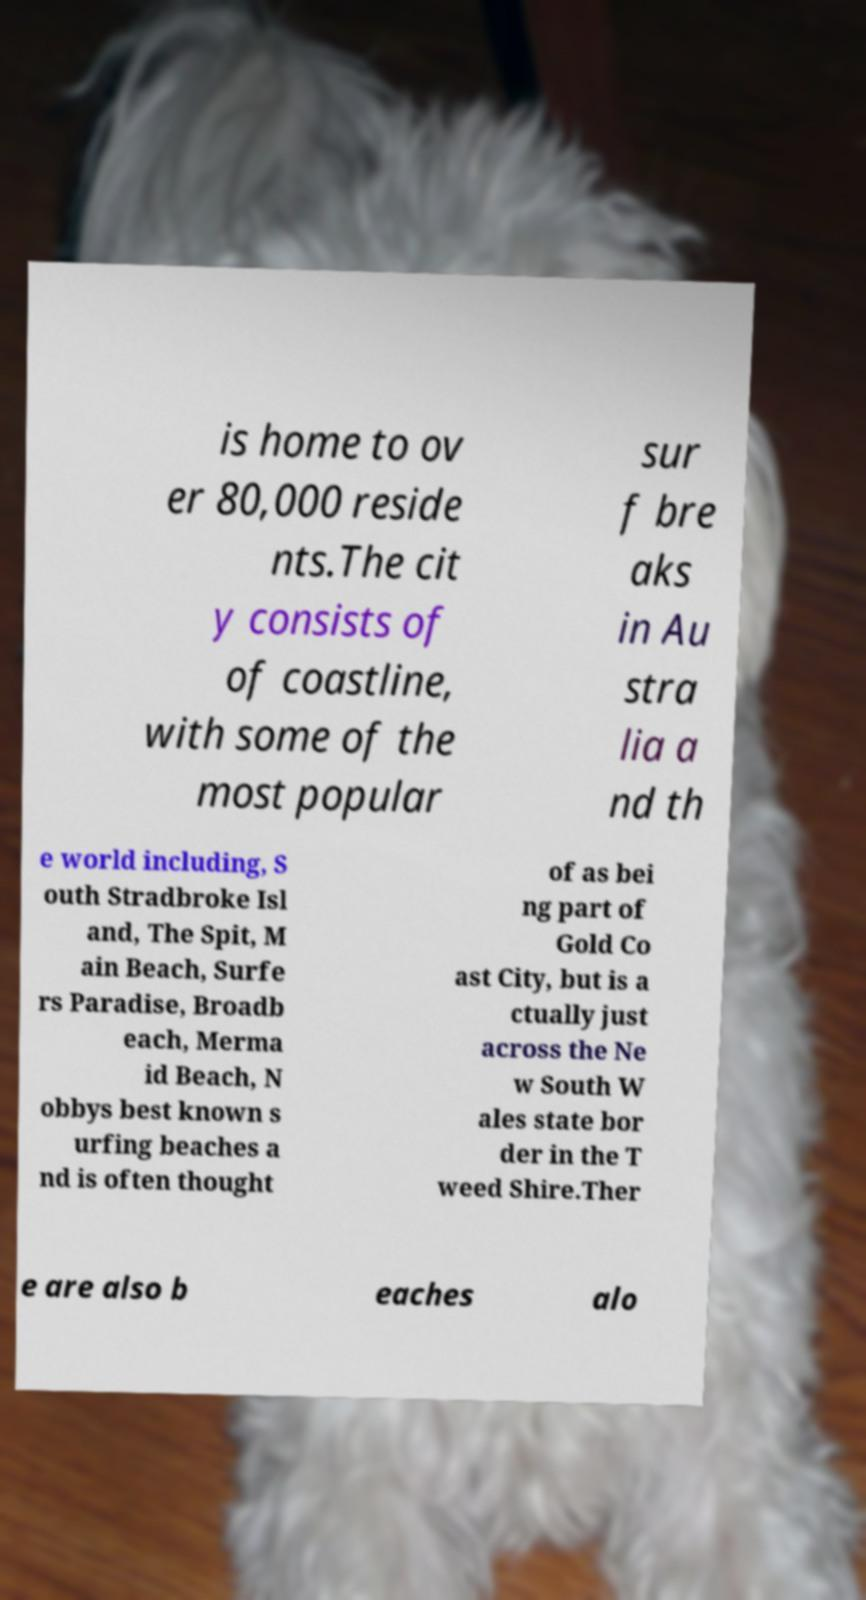Please identify and transcribe the text found in this image. is home to ov er 80,000 reside nts.The cit y consists of of coastline, with some of the most popular sur f bre aks in Au stra lia a nd th e world including, S outh Stradbroke Isl and, The Spit, M ain Beach, Surfe rs Paradise, Broadb each, Merma id Beach, N obbys best known s urfing beaches a nd is often thought of as bei ng part of Gold Co ast City, but is a ctually just across the Ne w South W ales state bor der in the T weed Shire.Ther e are also b eaches alo 